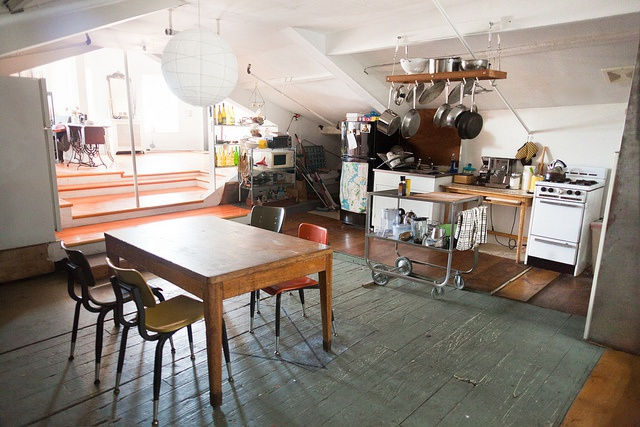Describe the objects in this image and their specific colors. I can see dining table in gray, white, brown, and maroon tones, refrigerator in gray tones, oven in gray, lightgray, darkgray, and black tones, chair in gray, black, maroon, and lightgray tones, and chair in gray, black, and darkgray tones in this image. 